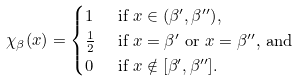<formula> <loc_0><loc_0><loc_500><loc_500>\chi _ { \beta } ( x ) & = \begin{cases} 1 & \text { if $x\in (\beta^{\prime},\beta^{\prime\prime})$} , \\ \frac { 1 } { 2 } & \text { if $x=\beta^{\prime}$ or $x=\beta^{\prime\prime}$, and} \\ 0 & \text { if $x\notin [\beta^{\prime},\beta^{\prime\prime}]$} . \end{cases}</formula> 